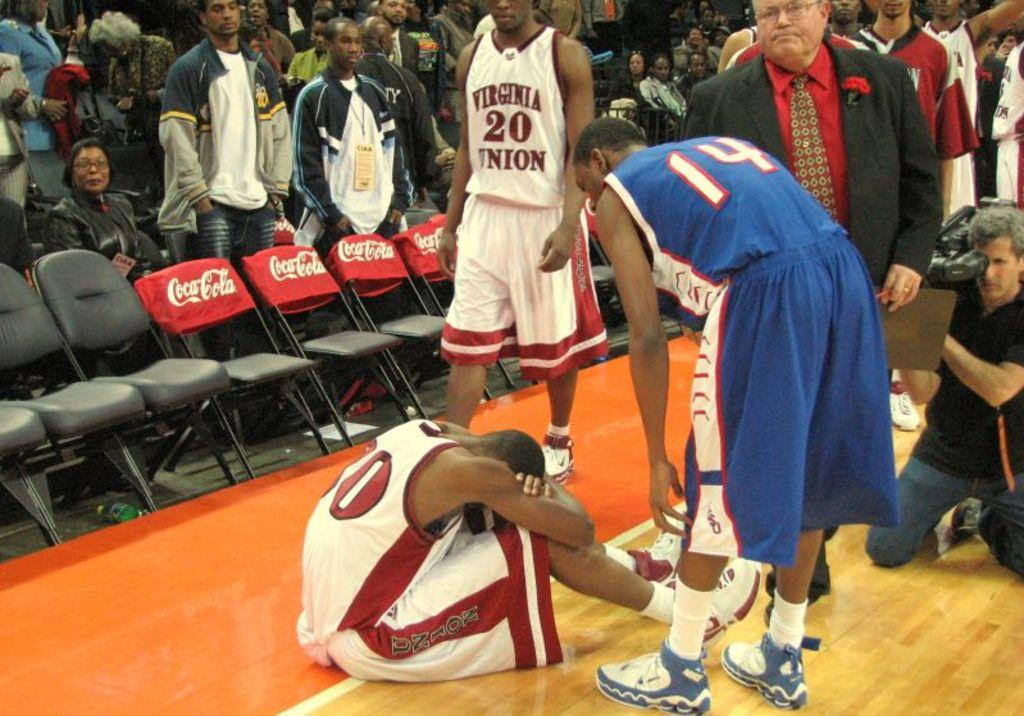<image>
Create a compact narrative representing the image presented. A basketball player for Virginia Union is sitting on the court upset. 